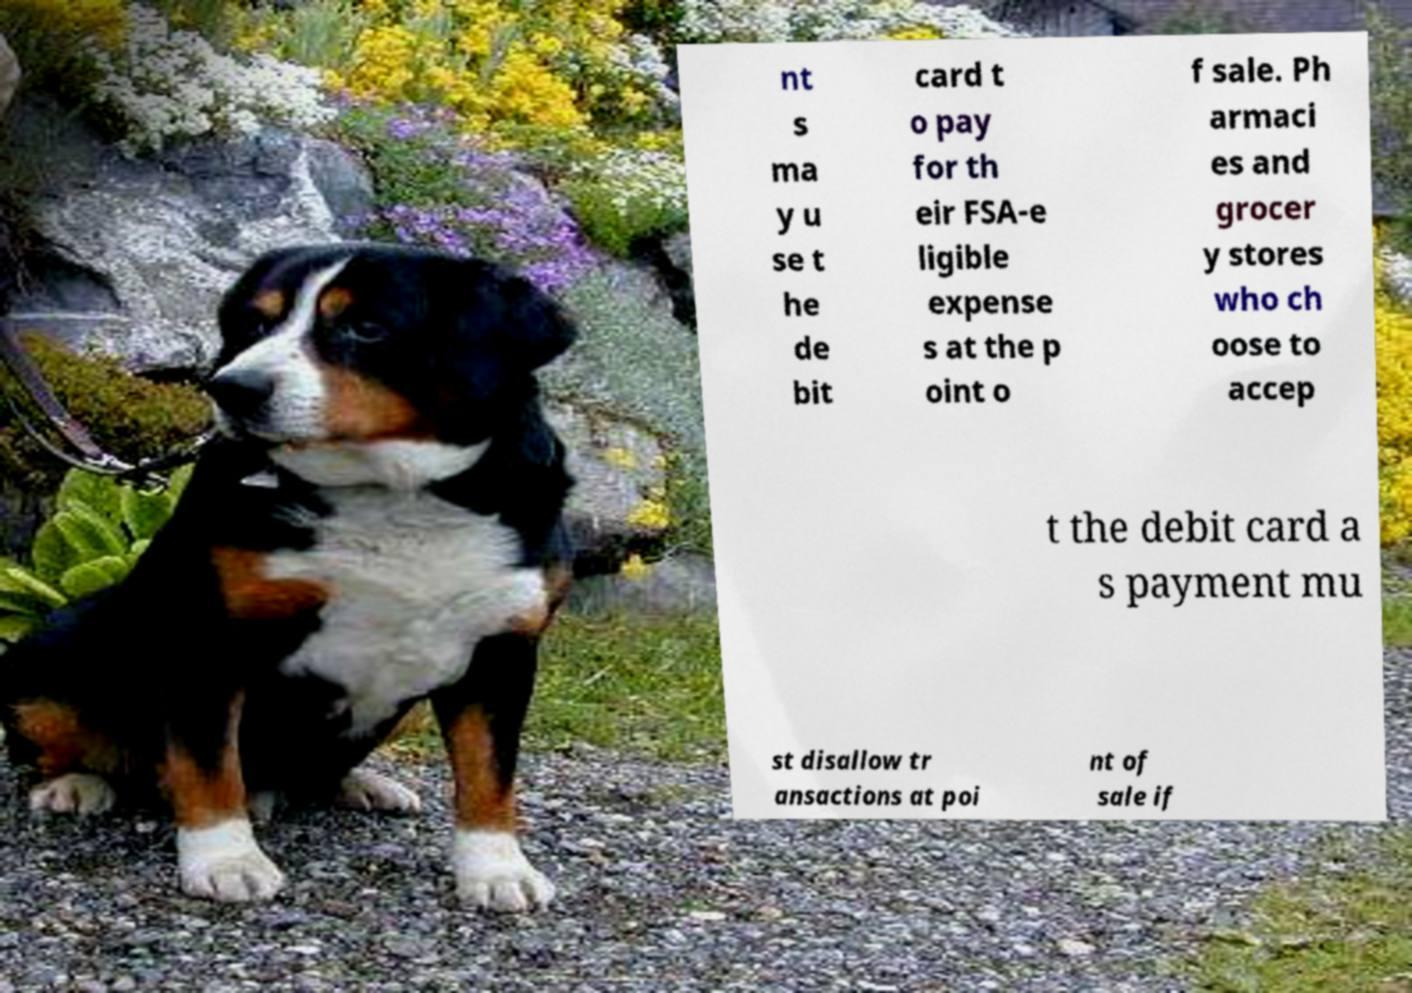Could you assist in decoding the text presented in this image and type it out clearly? nt s ma y u se t he de bit card t o pay for th eir FSA-e ligible expense s at the p oint o f sale. Ph armaci es and grocer y stores who ch oose to accep t the debit card a s payment mu st disallow tr ansactions at poi nt of sale if 